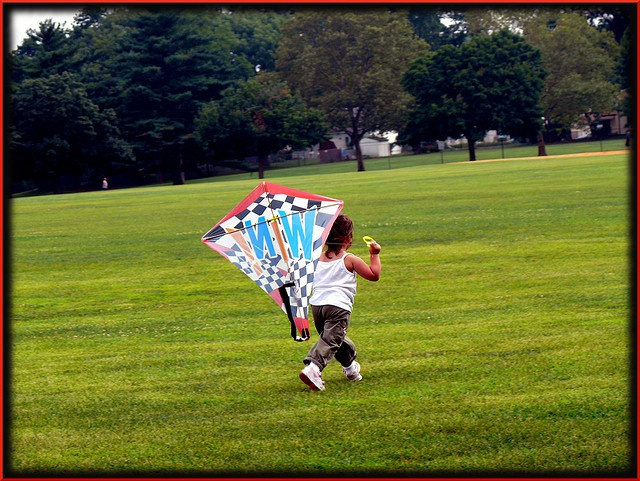Describe the objects in this image and their specific colors. I can see kite in red, white, salmon, gray, and lightpink tones, people in red, lavender, black, maroon, and gray tones, people in red, black, and gray tones, people in red, black, maroon, and navy tones, and people in red, black, purple, brown, and darkgray tones in this image. 